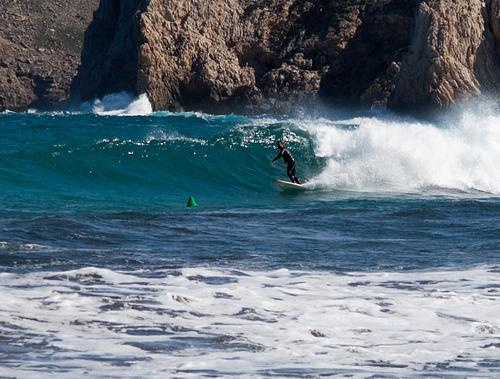Write a concise description of the primary subject in the image and their actions. A surfer wearing a wetsuit balances on a surfboard while catching a wave, as a green cone can be seen floating in the water nearby. Depict the central scene in the image by highlighting the main action and element. A daring surfer wearing a wetsuit rides a cresting wave on their surfboard, skillfully leaning into it, while a green cone stands out in the water floating nearby. Summarize the scene in the image by focusing on the most prominent action and element. A surfer in a wetsuit effortlessly navigates through a breaking wave on their surfboard, with a green cone conspicuously floating in the water. Furnish a succinct description of the chief character and their ongoing activity in the image. A skilled surfer wearing a wetsuit tackles a challenging wave on their surfboard with aplomb, as a green cone floats in the water nearby. Provide a brief summary of the main subject in the image and their actions. A surfer clad in a wetsuit expertly rides a large wave on their surfboard, while a green cone floats in the water not far from them. Describe the image by emphasizing the main character and their ongoing activity. A daring and determined surfer, clad in a black wetsuit, skillfully navigates a large wave on their surfboard, while a green cone floats nearby in the water. Explain the central theme of the image by highlighting the main character and their actions. A courageous surfer in a black wetsuit rides a breaking wave with panache, skillfully leaning on their surfboard, while a green cone floats in the water close by. Elaborate on the primary activity in the image and the key object involved. A surfer in a wetsuit boldly takes on a powerful wave by skillfully leaning on their surfboard, as a green warning cone floats nearby signaling the presence of rocks. State the most eye-catching activity occurring in the image along with the key entities. A surfer wearing a black wetsuit rides a large wave, skillfully leaning to the side, with a green buoy floating in the water. Mention the central action taking place in the image and the main object involved. A surfer is skillfully riding a wave on their surfboard, with a green cone floating nearby in the water. Notice the family having a picnic on the beach in the background. There is no mention of a family having a picnic or even a beach in the image captions, making this a nonexistent element. Notice how the sunset is creating a beautiful orange and purple hue in the sky. There is no mention of a sunset or any specific colors in the sky, making this a nonexistent attribute in the image. Observe the interaction between the dolphins and the surfer. There are no dolphins mentioned in the image captions, making this a nonexistent interaction between the surfer and nonexistent elements. Identify the purple jellyfish in the clear blue water near the rocks. There is no mention of a purple jellyfish or any other sea creature in the image captions, making this a nonexistent object. Do you notice how the lighthouse on the cliff is warning boats about the rocky shore? There is no mention of a lighthouse in the image captions, making it a nonexistent object. Look for a pink inflatable raft floating near the green cone. There is no mention of a pink inflatable raft in any of the image captions, making it a nonexistent object. Observe how the surfer is high-fiving his friend on a nearby surfboard. There is no mention of a friend on a nearby surfboard, nor that the surfer is high-fiving anyone, making this a nonexistent interaction. Look at the surfer's bright red wetsuit with yellow stripes. The surfer's wetsuit is mentioned to be black, not red with yellow stripes, making this a nonexistent attribute. Can you spot the seagulls flying above the surfer? Seagulls are not mentioned in any of the image captions, making them nonexistent elements in the image. Can you see how the surfer is performing a trick in the air, leaving his surfboard behind? The captions detail the surfer on the surfboard, there is no mention of the surfer performing an aerial trick or leaving his surfboard, making this a nonexistent activity. 